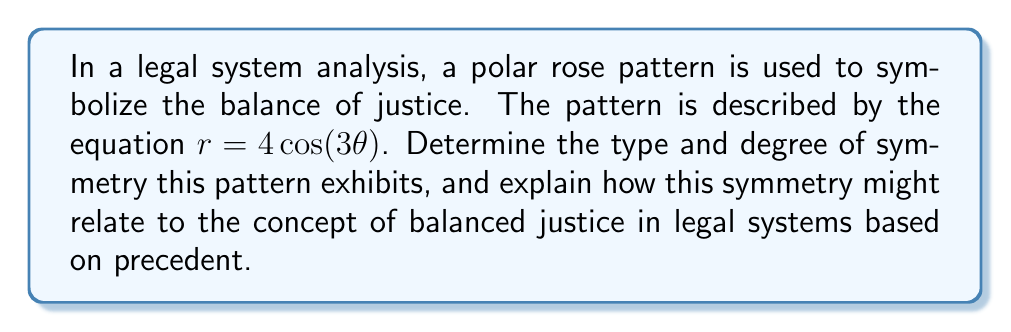Give your solution to this math problem. To analyze the symmetry of this polar rose pattern, we'll follow these steps:

1) First, let's consider the general form of a polar rose: $r = a\cos(n\theta)$ or $r = a\sin(n\theta)$
   Our equation $r = 4\cos(3\theta)$ fits this form with $a = 4$ and $n = 3$.

2) The number of petals in a polar rose is determined by $n$:
   - If $n$ is odd, there are $n$ petals.
   - If $n$ is even, there are $2n$ petals.
   In our case, $n = 3$ (odd), so this rose has 3 petals.

3) The symmetry of a polar rose depends on $n$:
   - It always has rotational symmetry of order $n$.
   - It always has $n$ lines of reflective symmetry.

4) For our rose:
   - It has rotational symmetry of order 3, meaning it looks the same after rotations of $\frac{360°}{3} = 120°$.
   - It has 3 lines of reflective symmetry, occurring at angles $\frac{k\pi}{3}$ where $k = 0, 1, 2$.

5) To visualize this, we can plot the rose:

[asy]
import graph;
size(200);
real r(real theta) {return 4*cos(3*theta);}
path g=polargraph(r,0,2pi);
draw(g,blue);
draw((-4,0)--(4,0),dashed);
draw((0,-4)--(0,4),dashed);
draw((2*sqrt(3),-2)--(-2*sqrt(3),2),dashed);
[/asy]

6) In the context of legal systems based on precedent:
   - The 3-fold rotational symmetry could represent the balance between three key elements: legislation, judicial interpretation, and societal norms.
   - The 3 lines of reflective symmetry might symbolize the checks and balances between the three branches of government: executive, legislative, and judicial.
   - The overall symmetry suggests that changes in one aspect of the legal system should be reflected in others to maintain balance.

This symmetrical pattern emphasizes the importance of consistency and balance in a legal system based on precedent, where each "petal" or aspect of the system must be in harmony with the others to ensure fair and just outcomes.
Answer: The polar rose pattern $r = 4\cos(3\theta)$ exhibits 3-fold rotational symmetry and 3 lines of reflective symmetry. This symmetry symbolizes the balance and interconnectedness of different aspects of a legal system based on precedent. 